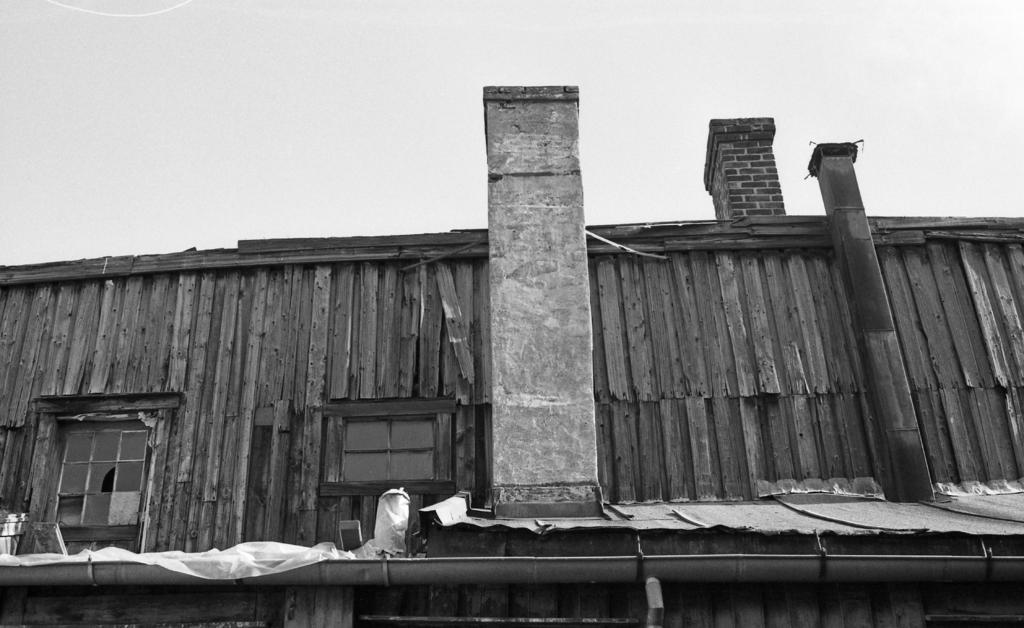Can you describe this image briefly? In the picture I can see a house, windows, roof and some other objects. In the background I can see the sky. This picture is black and white in color. 